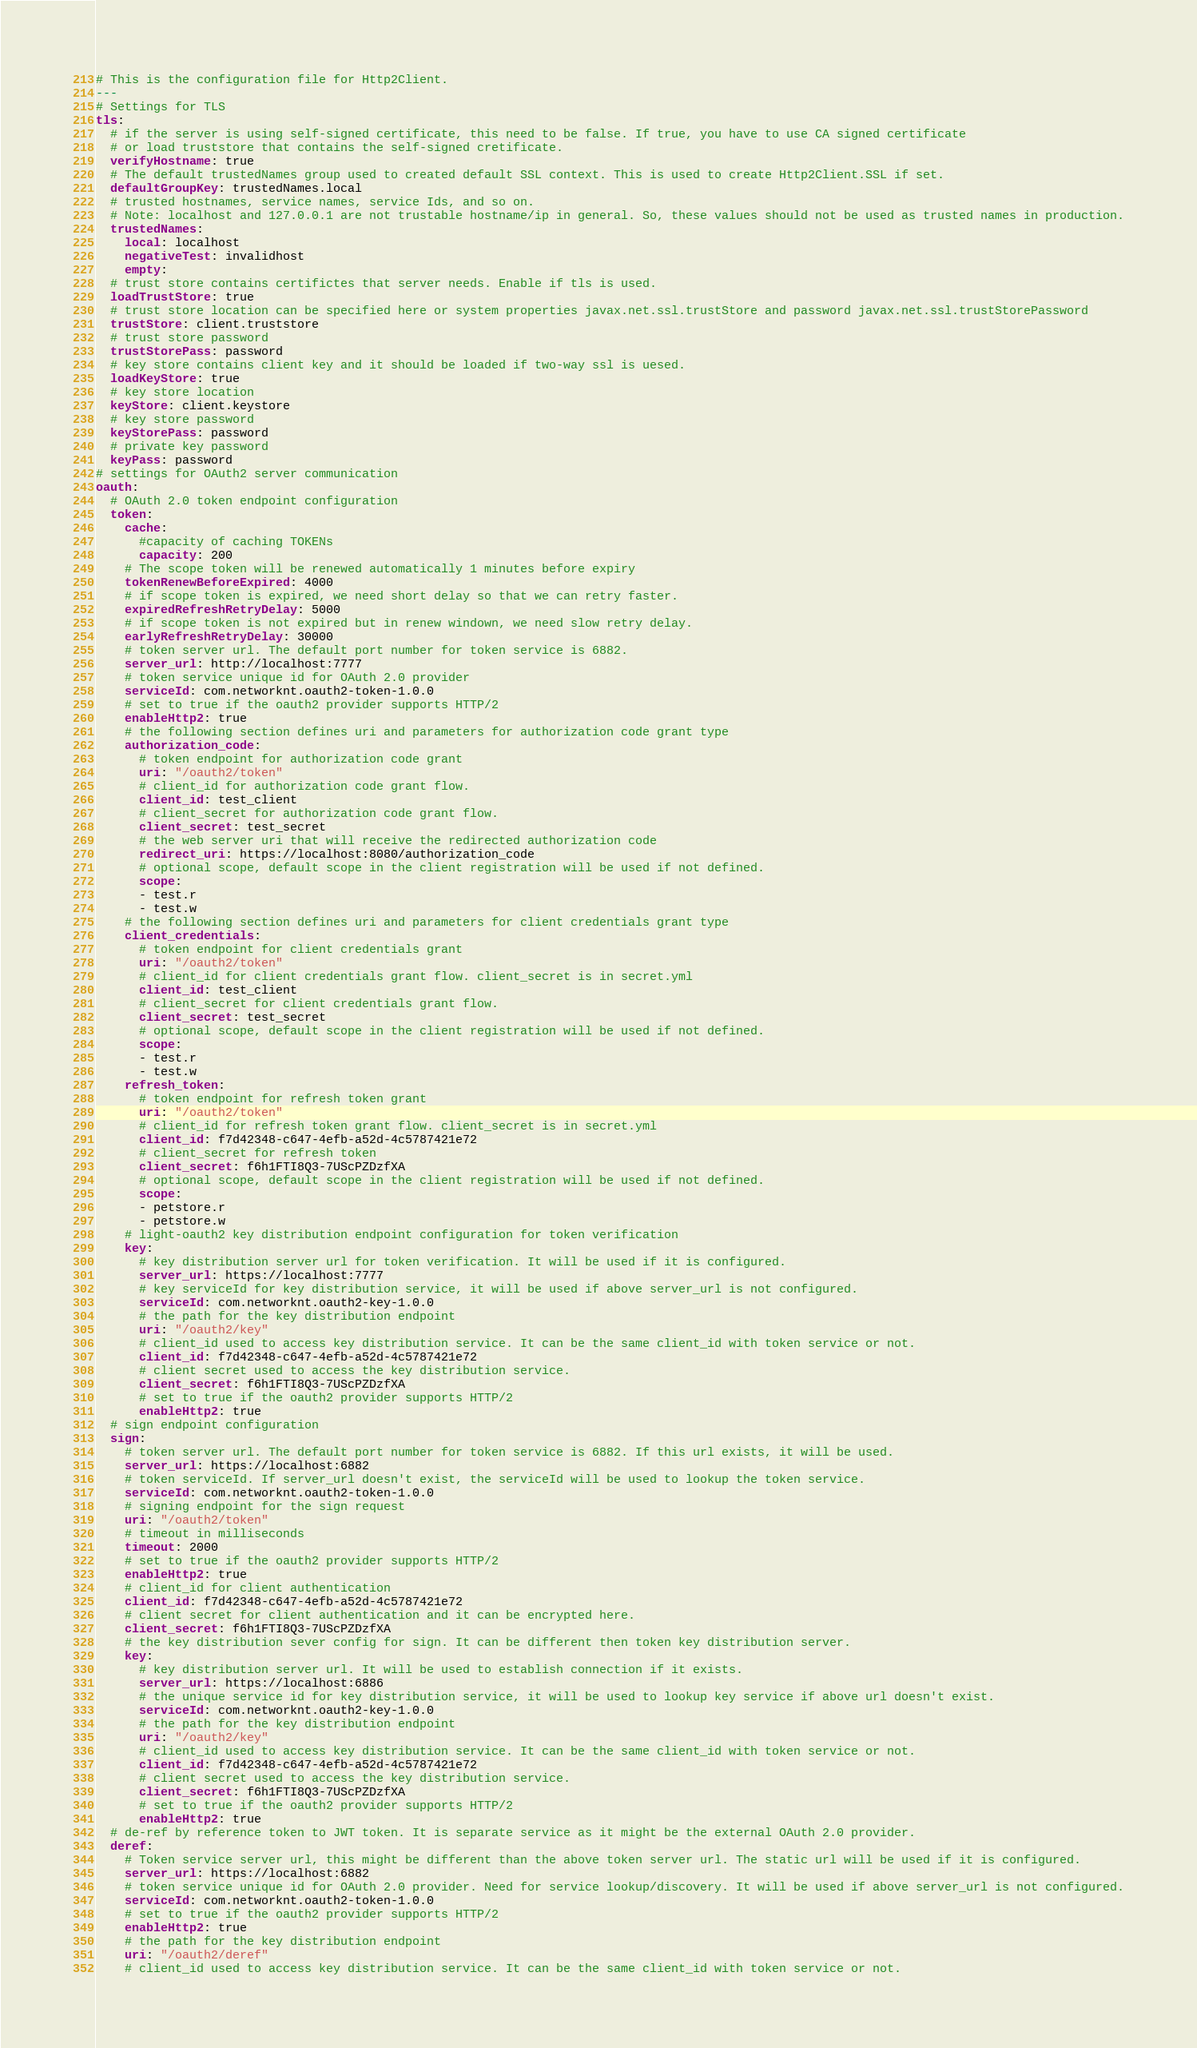<code> <loc_0><loc_0><loc_500><loc_500><_YAML_># This is the configuration file for Http2Client.
---
# Settings for TLS
tls:
  # if the server is using self-signed certificate, this need to be false. If true, you have to use CA signed certificate
  # or load truststore that contains the self-signed cretificate.
  verifyHostname: true
  # The default trustedNames group used to created default SSL context. This is used to create Http2Client.SSL if set.
  defaultGroupKey: trustedNames.local
  # trusted hostnames, service names, service Ids, and so on.
  # Note: localhost and 127.0.0.1 are not trustable hostname/ip in general. So, these values should not be used as trusted names in production.
  trustedNames: 
    local: localhost
    negativeTest: invalidhost 
    empty:
  # trust store contains certifictes that server needs. Enable if tls is used.
  loadTrustStore: true
  # trust store location can be specified here or system properties javax.net.ssl.trustStore and password javax.net.ssl.trustStorePassword
  trustStore: client.truststore
  # trust store password
  trustStorePass: password
  # key store contains client key and it should be loaded if two-way ssl is uesed.
  loadKeyStore: true
  # key store location
  keyStore: client.keystore
  # key store password
  keyStorePass: password
  # private key password
  keyPass: password
# settings for OAuth2 server communication
oauth:
  # OAuth 2.0 token endpoint configuration
  token:
    cache:
      #capacity of caching TOKENs
      capacity: 200
    # The scope token will be renewed automatically 1 minutes before expiry
    tokenRenewBeforeExpired: 4000
    # if scope token is expired, we need short delay so that we can retry faster.
    expiredRefreshRetryDelay: 5000
    # if scope token is not expired but in renew windown, we need slow retry delay.
    earlyRefreshRetryDelay: 30000
    # token server url. The default port number for token service is 6882.
    server_url: http://localhost:7777
    # token service unique id for OAuth 2.0 provider
    serviceId: com.networknt.oauth2-token-1.0.0
    # set to true if the oauth2 provider supports HTTP/2
    enableHttp2: true
    # the following section defines uri and parameters for authorization code grant type
    authorization_code:
      # token endpoint for authorization code grant
      uri: "/oauth2/token"
      # client_id for authorization code grant flow.
      client_id: test_client
      # client_secret for authorization code grant flow.
      client_secret: test_secret
      # the web server uri that will receive the redirected authorization code
      redirect_uri: https://localhost:8080/authorization_code
      # optional scope, default scope in the client registration will be used if not defined.
      scope:
      - test.r
      - test.w
    # the following section defines uri and parameters for client credentials grant type
    client_credentials:
      # token endpoint for client credentials grant
      uri: "/oauth2/token"
      # client_id for client credentials grant flow. client_secret is in secret.yml
      client_id: test_client
      # client_secret for client credentials grant flow.
      client_secret: test_secret
      # optional scope, default scope in the client registration will be used if not defined.
      scope:
      - test.r
      - test.w
    refresh_token:
      # token endpoint for refresh token grant
      uri: "/oauth2/token"
      # client_id for refresh token grant flow. client_secret is in secret.yml
      client_id: f7d42348-c647-4efb-a52d-4c5787421e72
      # client_secret for refresh token
      client_secret: f6h1FTI8Q3-7UScPZDzfXA
      # optional scope, default scope in the client registration will be used if not defined.
      scope:
      - petstore.r
      - petstore.w
    # light-oauth2 key distribution endpoint configuration for token verification
    key:
      # key distribution server url for token verification. It will be used if it is configured.
      server_url: https://localhost:7777
      # key serviceId for key distribution service, it will be used if above server_url is not configured.
      serviceId: com.networknt.oauth2-key-1.0.0
      # the path for the key distribution endpoint
      uri: "/oauth2/key"
      # client_id used to access key distribution service. It can be the same client_id with token service or not.
      client_id: f7d42348-c647-4efb-a52d-4c5787421e72
      # client secret used to access the key distribution service.
      client_secret: f6h1FTI8Q3-7UScPZDzfXA
      # set to true if the oauth2 provider supports HTTP/2
      enableHttp2: true
  # sign endpoint configuration
  sign:
    # token server url. The default port number for token service is 6882. If this url exists, it will be used.
    server_url: https://localhost:6882
    # token serviceId. If server_url doesn't exist, the serviceId will be used to lookup the token service.
    serviceId: com.networknt.oauth2-token-1.0.0
    # signing endpoint for the sign request
    uri: "/oauth2/token"
    # timeout in milliseconds
    timeout: 2000
    # set to true if the oauth2 provider supports HTTP/2
    enableHttp2: true
    # client_id for client authentication
    client_id: f7d42348-c647-4efb-a52d-4c5787421e72
    # client secret for client authentication and it can be encrypted here.
    client_secret: f6h1FTI8Q3-7UScPZDzfXA
    # the key distribution sever config for sign. It can be different then token key distribution server.
    key:
      # key distribution server url. It will be used to establish connection if it exists.
      server_url: https://localhost:6886
      # the unique service id for key distribution service, it will be used to lookup key service if above url doesn't exist.
      serviceId: com.networknt.oauth2-key-1.0.0
      # the path for the key distribution endpoint
      uri: "/oauth2/key"
      # client_id used to access key distribution service. It can be the same client_id with token service or not.
      client_id: f7d42348-c647-4efb-a52d-4c5787421e72
      # client secret used to access the key distribution service.
      client_secret: f6h1FTI8Q3-7UScPZDzfXA
      # set to true if the oauth2 provider supports HTTP/2
      enableHttp2: true
  # de-ref by reference token to JWT token. It is separate service as it might be the external OAuth 2.0 provider.
  deref:
    # Token service server url, this might be different than the above token server url. The static url will be used if it is configured.
    server_url: https://localhost:6882
    # token service unique id for OAuth 2.0 provider. Need for service lookup/discovery. It will be used if above server_url is not configured.
    serviceId: com.networknt.oauth2-token-1.0.0
    # set to true if the oauth2 provider supports HTTP/2
    enableHttp2: true
    # the path for the key distribution endpoint
    uri: "/oauth2/deref"
    # client_id used to access key distribution service. It can be the same client_id with token service or not.</code> 